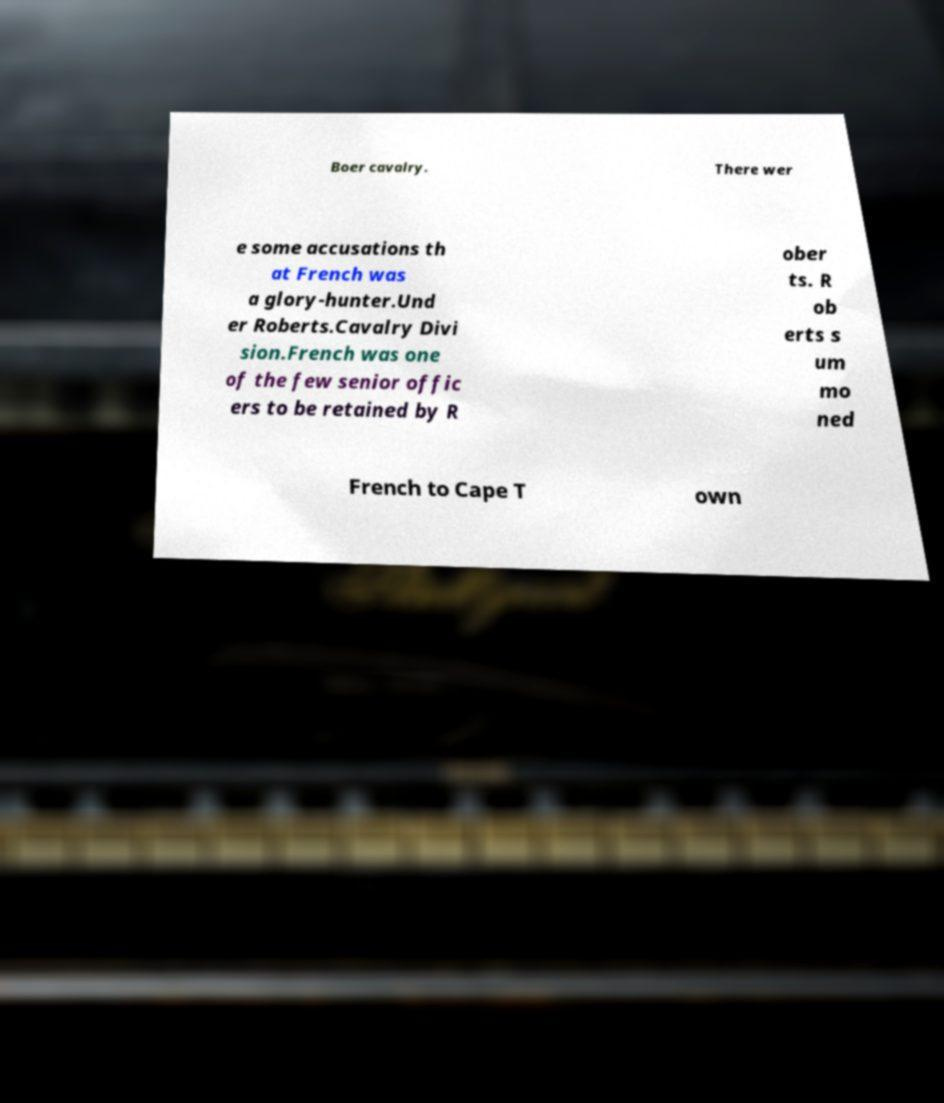Please read and relay the text visible in this image. What does it say? Boer cavalry. There wer e some accusations th at French was a glory-hunter.Und er Roberts.Cavalry Divi sion.French was one of the few senior offic ers to be retained by R ober ts. R ob erts s um mo ned French to Cape T own 